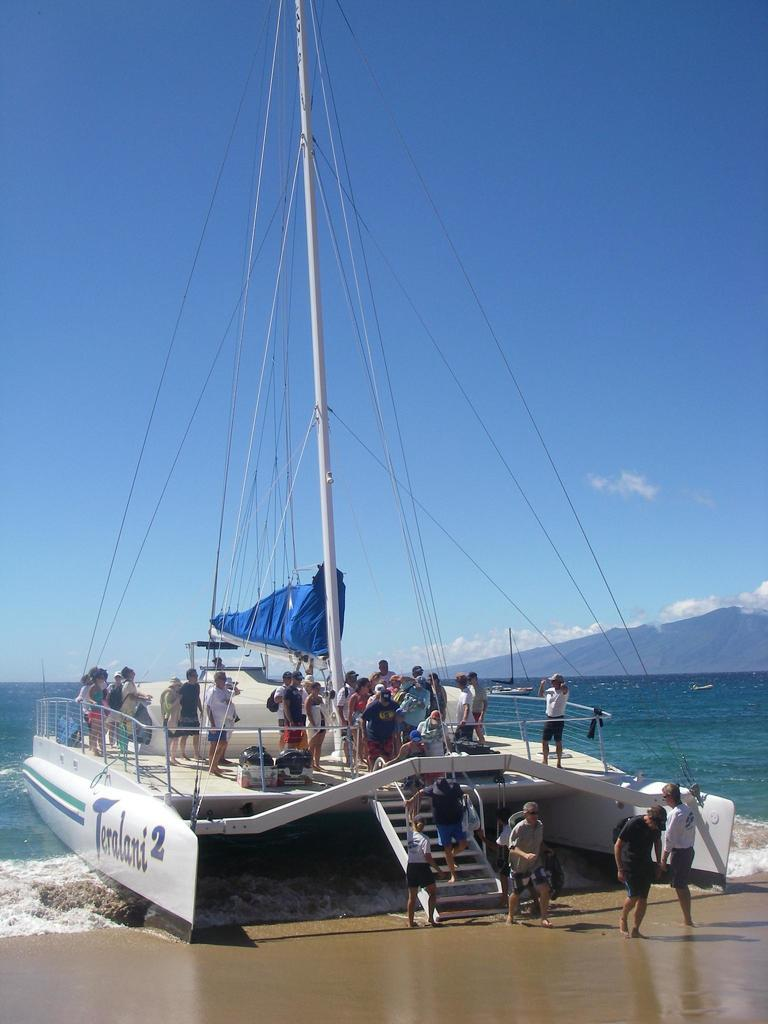What is the main subject in the center of the image? There is a ship in the center of the image. Where is the ship located? The ship is on the sea. Are there any people on the ship? Yes, there are persons on the ship. What else can be seen on the ship? There is cloth and bags visible on the ship. What can be seen in the background of the image? There is water, hills, and the sky visible in the background of the image. How many kittens are playing with the fuel on the ship? There are no kittens or fuel present in the image. What type of camera is being used to take the picture of the ship? There is no camera mentioned or visible in the image. 